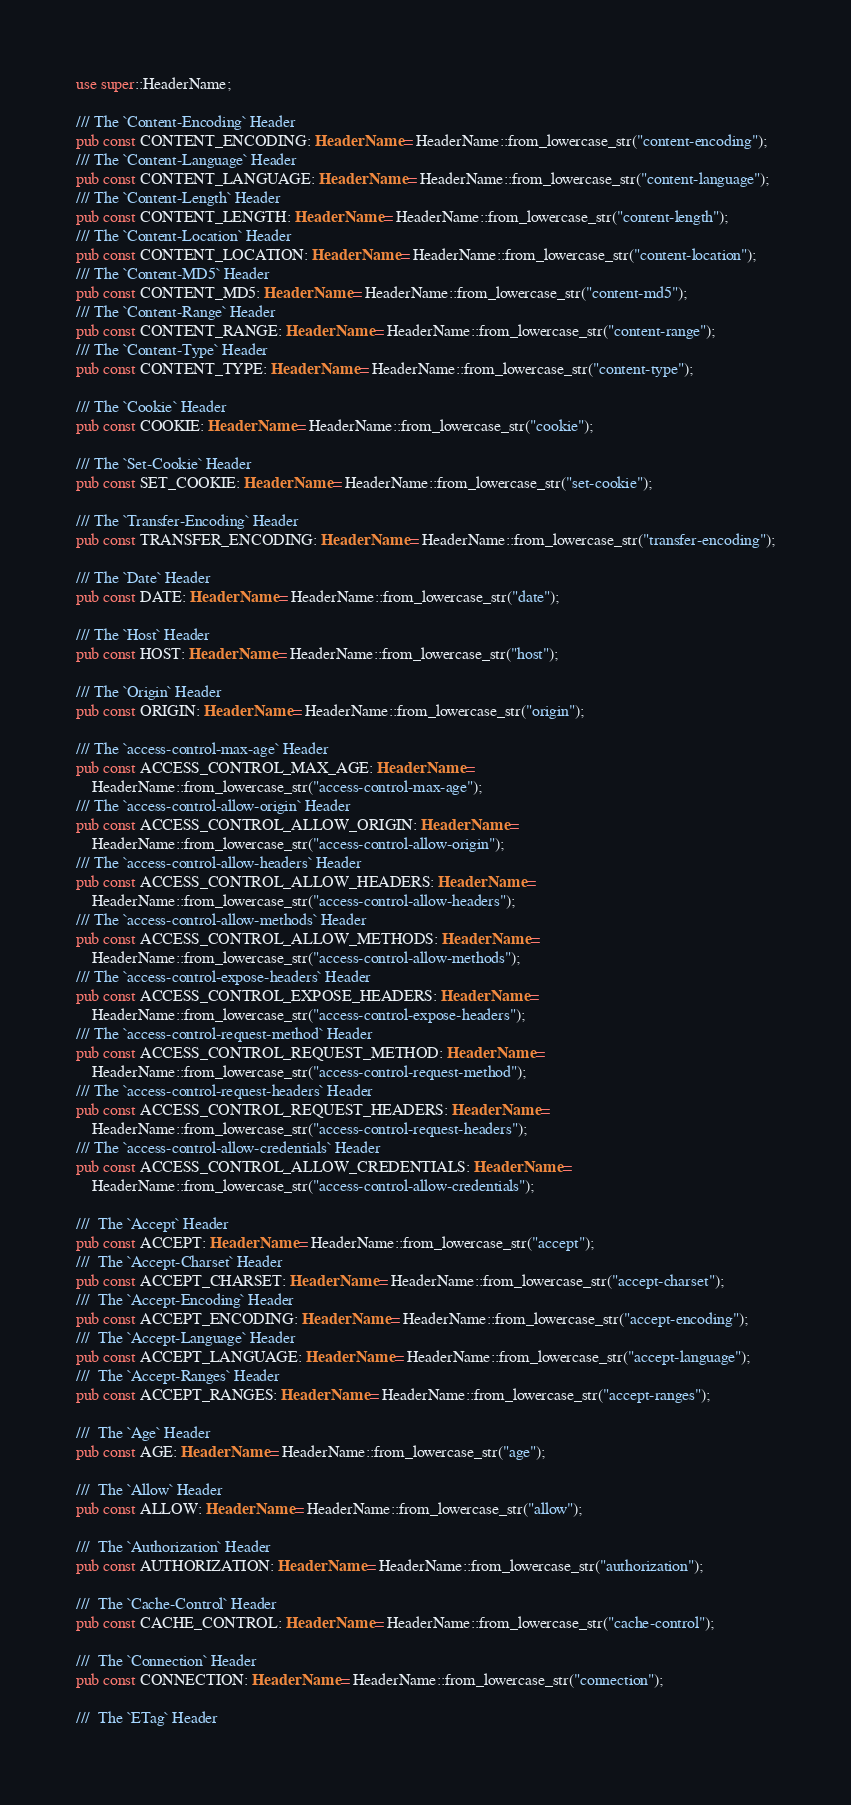<code> <loc_0><loc_0><loc_500><loc_500><_Rust_>use super::HeaderName;

/// The `Content-Encoding` Header
pub const CONTENT_ENCODING: HeaderName = HeaderName::from_lowercase_str("content-encoding");
/// The `Content-Language` Header
pub const CONTENT_LANGUAGE: HeaderName = HeaderName::from_lowercase_str("content-language");
/// The `Content-Length` Header
pub const CONTENT_LENGTH: HeaderName = HeaderName::from_lowercase_str("content-length");
/// The `Content-Location` Header
pub const CONTENT_LOCATION: HeaderName = HeaderName::from_lowercase_str("content-location");
/// The `Content-MD5` Header
pub const CONTENT_MD5: HeaderName = HeaderName::from_lowercase_str("content-md5");
/// The `Content-Range` Header
pub const CONTENT_RANGE: HeaderName = HeaderName::from_lowercase_str("content-range");
/// The `Content-Type` Header
pub const CONTENT_TYPE: HeaderName = HeaderName::from_lowercase_str("content-type");

/// The `Cookie` Header
pub const COOKIE: HeaderName = HeaderName::from_lowercase_str("cookie");

/// The `Set-Cookie` Header
pub const SET_COOKIE: HeaderName = HeaderName::from_lowercase_str("set-cookie");

/// The `Transfer-Encoding` Header
pub const TRANSFER_ENCODING: HeaderName = HeaderName::from_lowercase_str("transfer-encoding");

/// The `Date` Header
pub const DATE: HeaderName = HeaderName::from_lowercase_str("date");

/// The `Host` Header
pub const HOST: HeaderName = HeaderName::from_lowercase_str("host");

/// The `Origin` Header
pub const ORIGIN: HeaderName = HeaderName::from_lowercase_str("origin");

/// The `access-control-max-age` Header
pub const ACCESS_CONTROL_MAX_AGE: HeaderName =
    HeaderName::from_lowercase_str("access-control-max-age");
/// The `access-control-allow-origin` Header
pub const ACCESS_CONTROL_ALLOW_ORIGIN: HeaderName =
    HeaderName::from_lowercase_str("access-control-allow-origin");
/// The `access-control-allow-headers` Header
pub const ACCESS_CONTROL_ALLOW_HEADERS: HeaderName =
    HeaderName::from_lowercase_str("access-control-allow-headers");
/// The `access-control-allow-methods` Header
pub const ACCESS_CONTROL_ALLOW_METHODS: HeaderName =
    HeaderName::from_lowercase_str("access-control-allow-methods");
/// The `access-control-expose-headers` Header
pub const ACCESS_CONTROL_EXPOSE_HEADERS: HeaderName =
    HeaderName::from_lowercase_str("access-control-expose-headers");
/// The `access-control-request-method` Header
pub const ACCESS_CONTROL_REQUEST_METHOD: HeaderName =
    HeaderName::from_lowercase_str("access-control-request-method");
/// The `access-control-request-headers` Header
pub const ACCESS_CONTROL_REQUEST_HEADERS: HeaderName =
    HeaderName::from_lowercase_str("access-control-request-headers");
/// The `access-control-allow-credentials` Header
pub const ACCESS_CONTROL_ALLOW_CREDENTIALS: HeaderName =
    HeaderName::from_lowercase_str("access-control-allow-credentials");

///  The `Accept` Header
pub const ACCEPT: HeaderName = HeaderName::from_lowercase_str("accept");
///  The `Accept-Charset` Header
pub const ACCEPT_CHARSET: HeaderName = HeaderName::from_lowercase_str("accept-charset");
///  The `Accept-Encoding` Header
pub const ACCEPT_ENCODING: HeaderName = HeaderName::from_lowercase_str("accept-encoding");
///  The `Accept-Language` Header
pub const ACCEPT_LANGUAGE: HeaderName = HeaderName::from_lowercase_str("accept-language");
///  The `Accept-Ranges` Header
pub const ACCEPT_RANGES: HeaderName = HeaderName::from_lowercase_str("accept-ranges");

///  The `Age` Header
pub const AGE: HeaderName = HeaderName::from_lowercase_str("age");

///  The `Allow` Header
pub const ALLOW: HeaderName = HeaderName::from_lowercase_str("allow");

///  The `Authorization` Header
pub const AUTHORIZATION: HeaderName = HeaderName::from_lowercase_str("authorization");

///  The `Cache-Control` Header
pub const CACHE_CONTROL: HeaderName = HeaderName::from_lowercase_str("cache-control");

///  The `Connection` Header
pub const CONNECTION: HeaderName = HeaderName::from_lowercase_str("connection");

///  The `ETag` Header</code> 